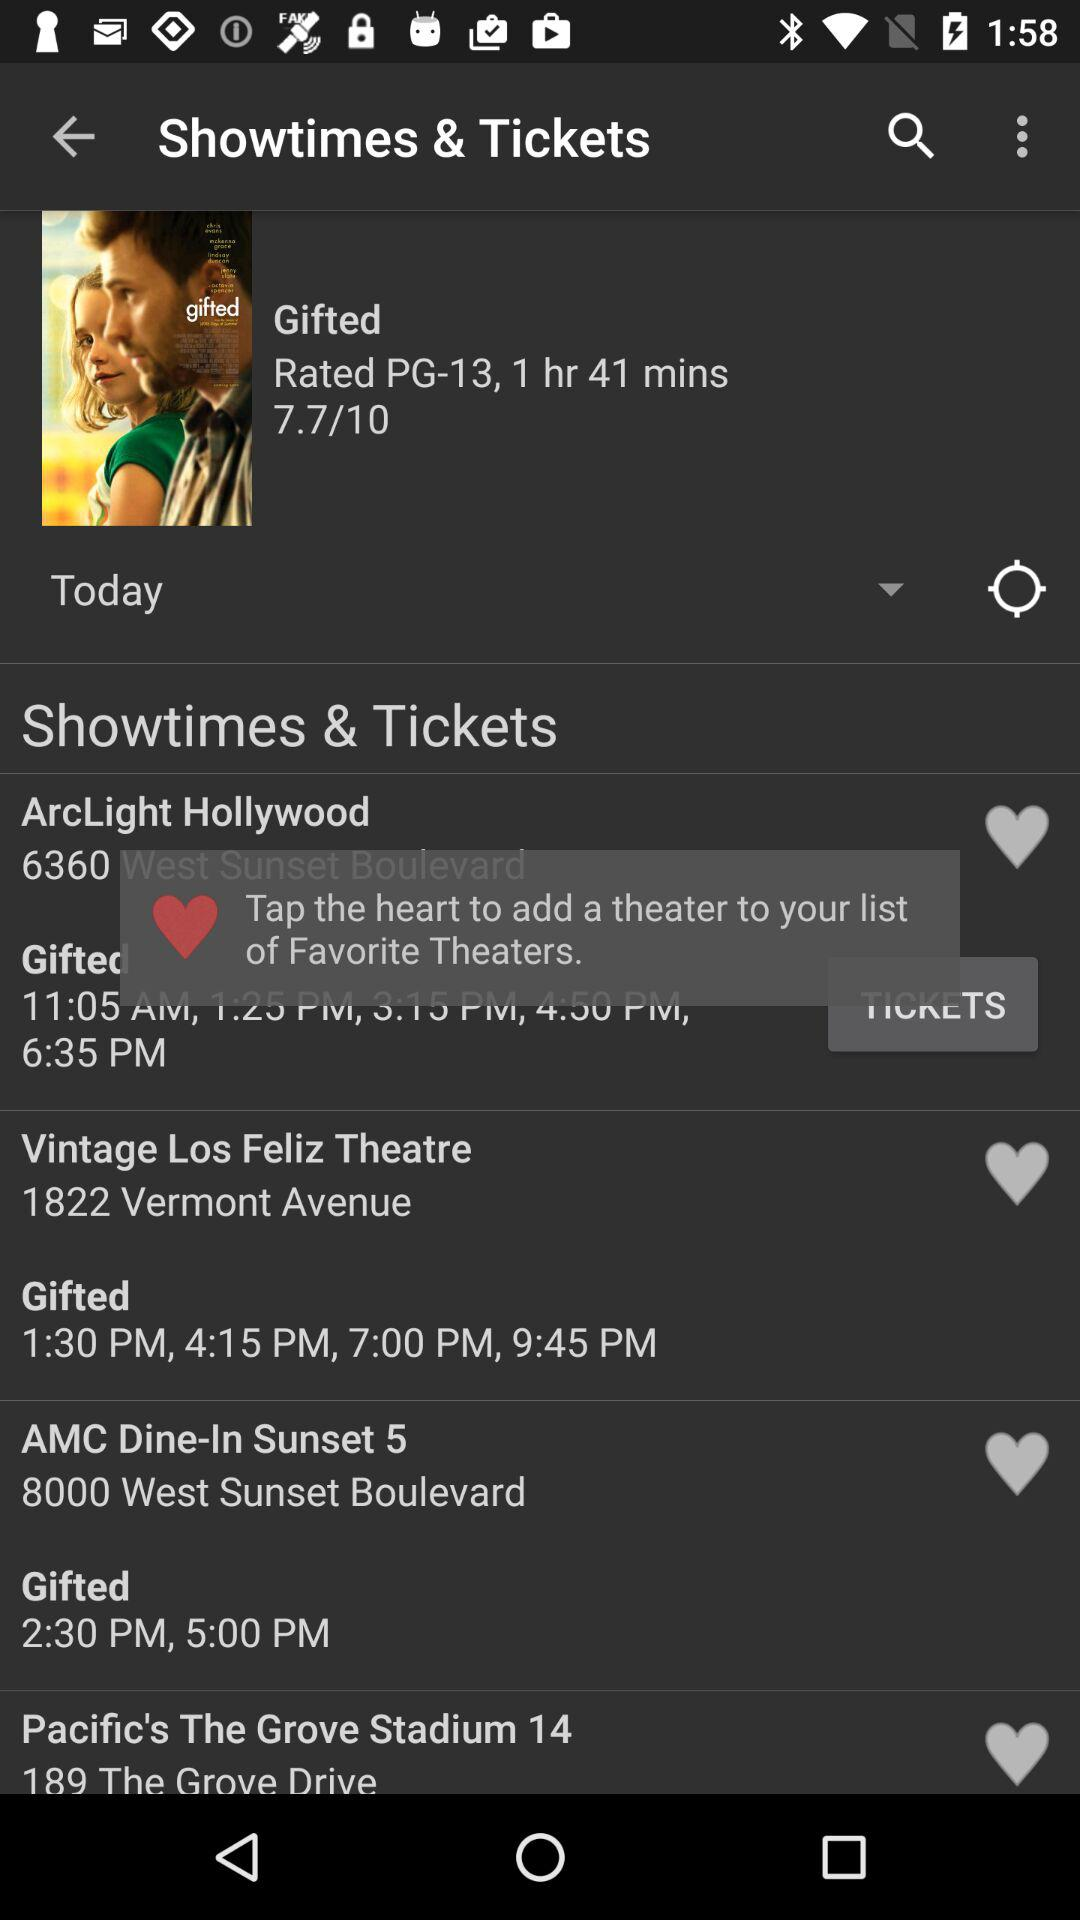What is the time of the show at "ArcLight Hollywood"? The time of the show at "ArcLight Hollywood" is 11:05 AM, 1:25 PM, 3:15 PM, 4:50 PM and 6:35 PM. 